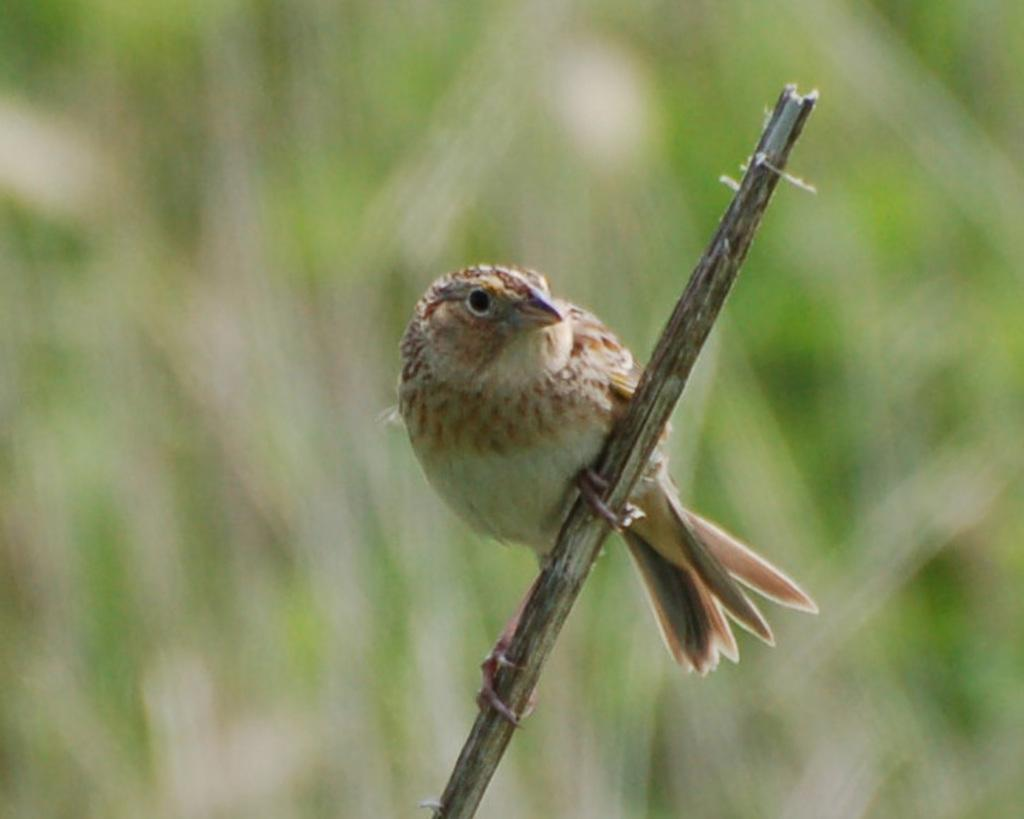What type of animal is in the image? There is a bird in the image. Where is the bird located in the image? The bird is on a stick. How many legs does the bird have in the image? The image does not show the bird's legs, so it cannot be determined from the image. 